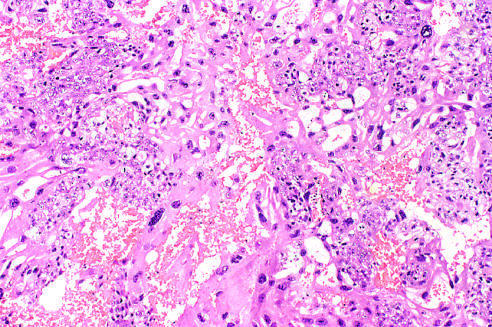what does this field contain?
Answer the question using a single word or phrase. Neoplastic cytotro-phoblast and multinucleate syncytiotrophoblast 